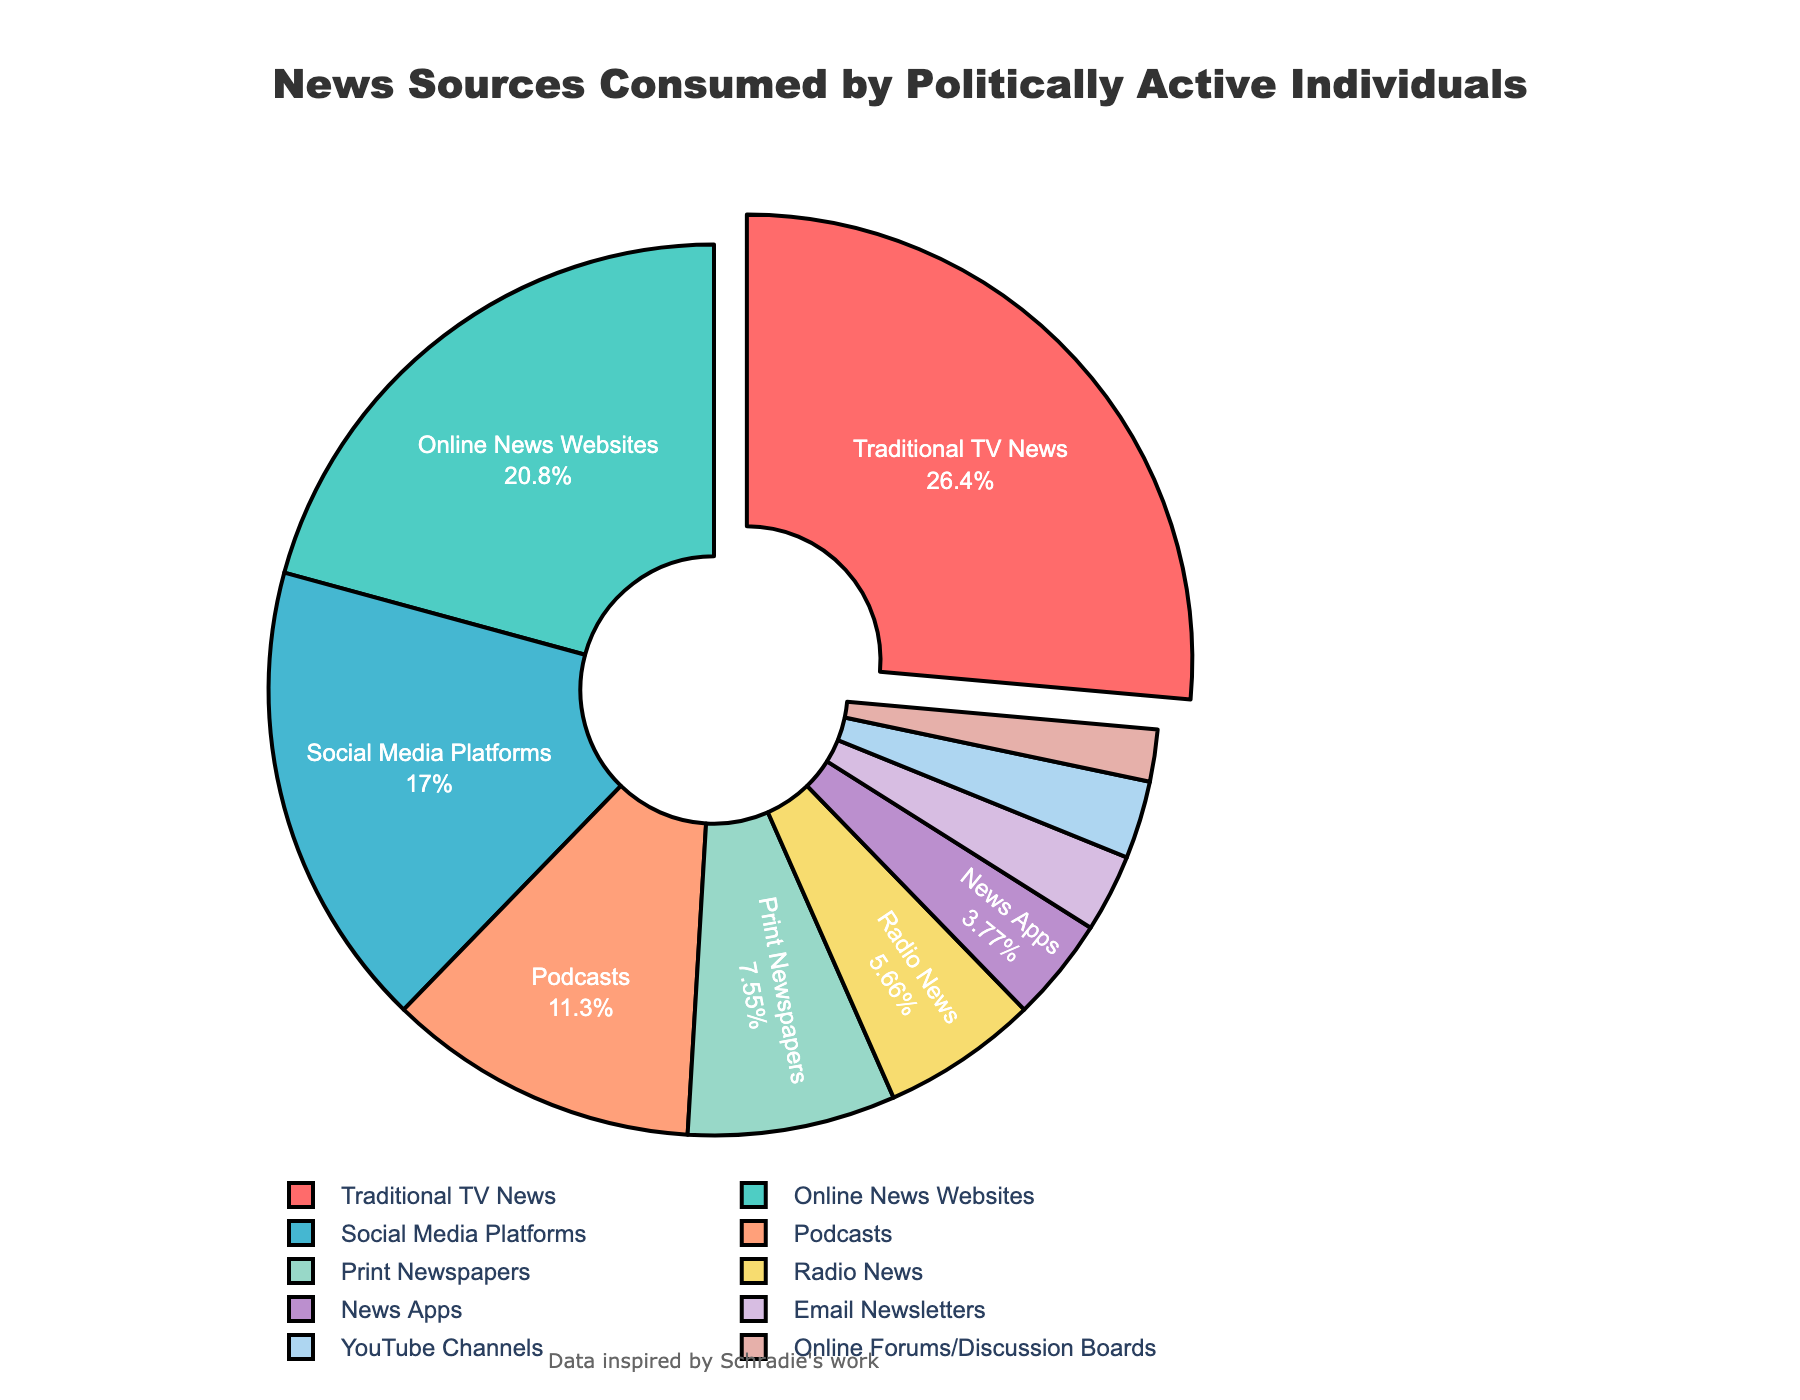What's the largest source of news consumption for politically active individuals? The slice with the largest proportion in the pie chart is "Traditional TV News" which is slightly separated to highlight it. Reading the percentage label confirms it as 28%.
Answer: Traditional TV News Which news sources are consumed more than 20%? By looking at the percentages on the chart, we see "Traditional TV News" at 28% and "Online News Websites" at 22%, both of which are over 20%.
Answer: Traditional TV News, Online News Websites Which news source has the smallest slice in the pie chart? The smallest slice in the pie chart is "Online Forums/Discussion Boards" with a 2% consumption rate. This can be confirmed by comparing the size of the slices visually.
Answer: Online Forums/Discussion Boards How many news sources are represented in the pie chart? By counting each label on the chart, we see there are 10 different news sources represented.
Answer: 10 What is the combined consumption percentage of "Podcasts" and "Print Newspapers"? "Podcasts" have a consumption rate of 12%, and "Print Newspapers" have 8%. Adding these together, we get 12% + 8% = 20%.
Answer: 20% Are more news sources consumed via "Social Media Platforms" or "Radio News"? According to the percentages on the chart, "Social Media Platforms" have 18% and "Radio News" has 6%. Social Media Platforms have a higher percentage.
Answer: Social Media Platforms What percentage of news consumption is from sources other than "Traditional TV News" and "Online News Websites"? Adding "Traditional TV News" and "Online News Websites" gives 28% + 22% = 50%. Since the total must be 100%, the remaining sources account for 100% - 50% = 50%.
Answer: 50% What sources are consumed less than 5%? By identifying slices with percentages under 5%, "News Apps" (4%), "Email Newsletters" (3%), "YouTube Channels" (3%), and "Online Forums/Discussion Boards" (2%) qualify.
Answer: News Apps, Email Newsletters, YouTube Channels, Online Forums/Discussion Boards Which source uses the greenish color slice? The color scheme in pie charts is usually unique to each slice. In the provided pie chart, the greenish color corresponds to "Online News Websites," which can be identified by visually matching colors to labels.
Answer: Online News Websites Comparing "Podcasts" and "Print Newspapers," which has a higher percentage and by how much? "Podcasts" have a 12% consumption rate, while "Print Newspapers" have 8%. The difference is 12% - 8% = 4%.
Answer: Podcasts by 4% 